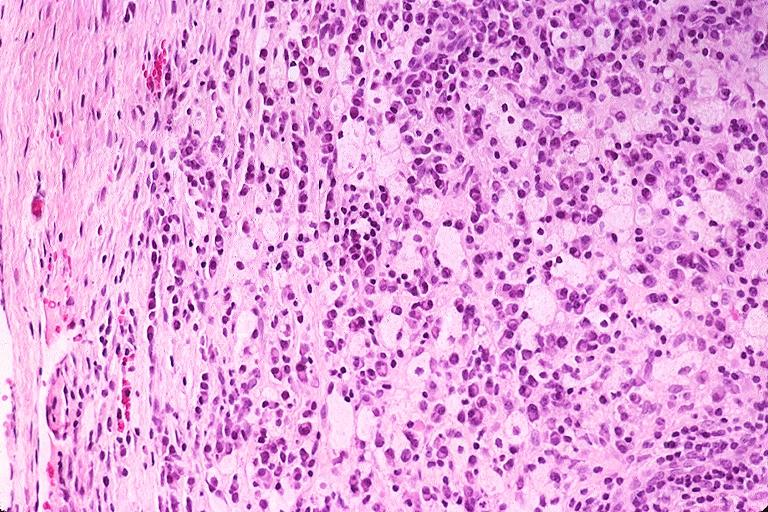s oral present?
Answer the question using a single word or phrase. Yes 